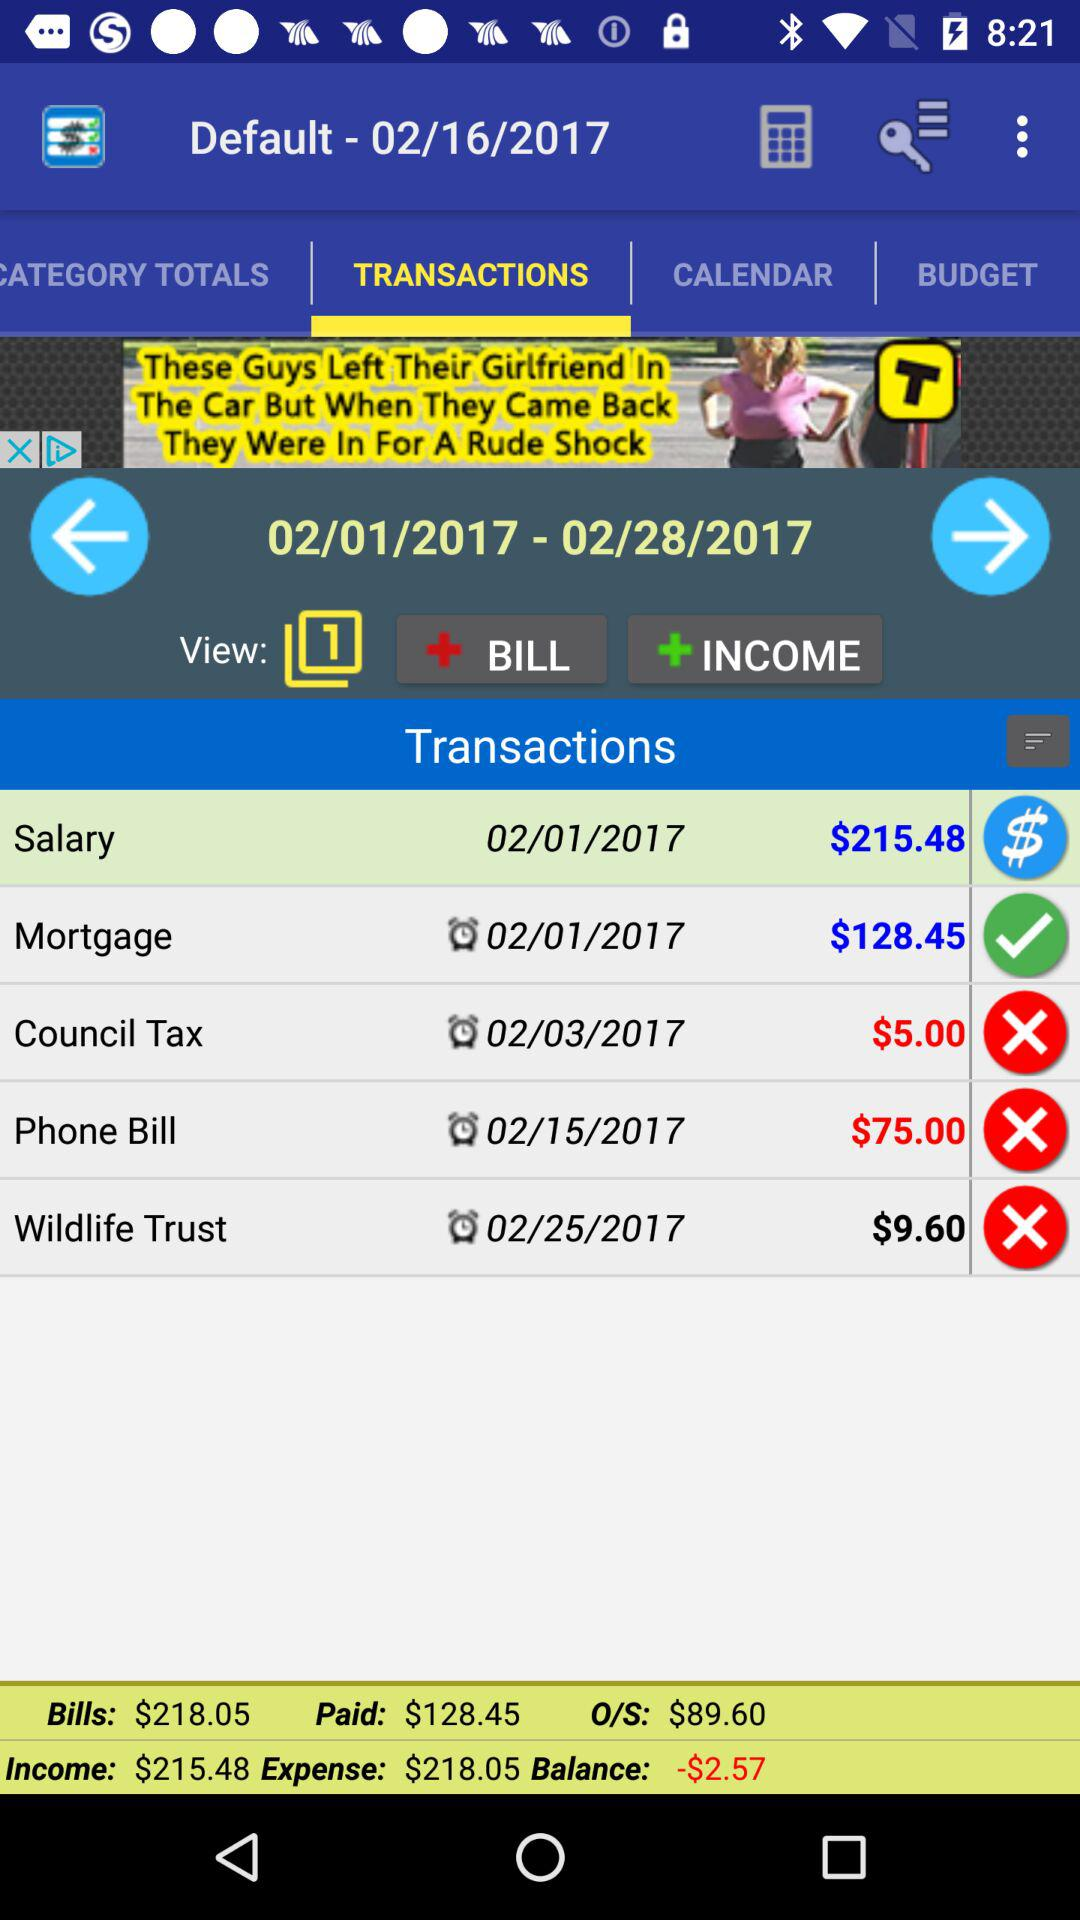What is the amount for the "Wildlife Trust"? The amount for the "Wildlife Trust" is $9.60. 